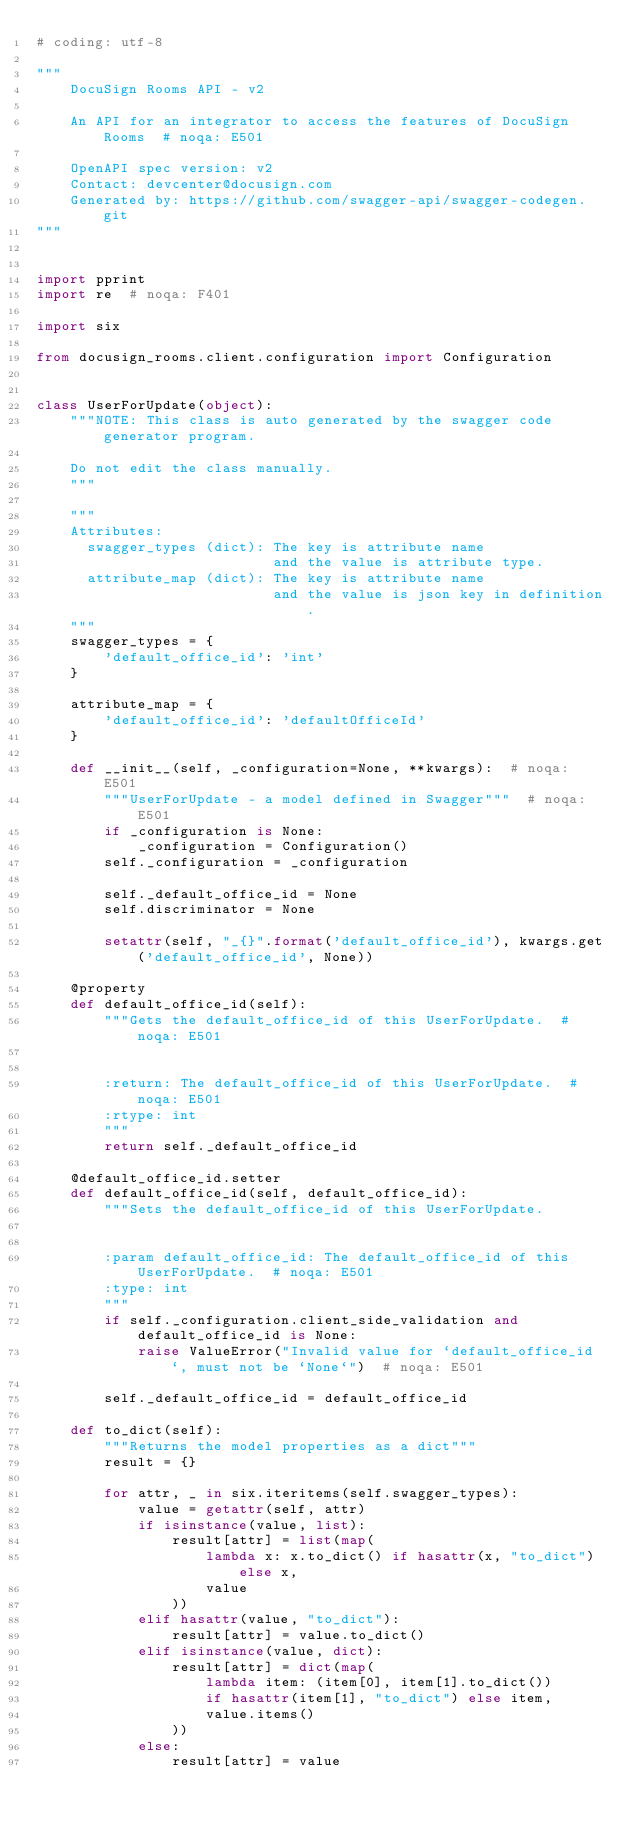Convert code to text. <code><loc_0><loc_0><loc_500><loc_500><_Python_># coding: utf-8

"""
    DocuSign Rooms API - v2

    An API for an integrator to access the features of DocuSign Rooms  # noqa: E501

    OpenAPI spec version: v2
    Contact: devcenter@docusign.com
    Generated by: https://github.com/swagger-api/swagger-codegen.git
"""


import pprint
import re  # noqa: F401

import six

from docusign_rooms.client.configuration import Configuration


class UserForUpdate(object):
    """NOTE: This class is auto generated by the swagger code generator program.

    Do not edit the class manually.
    """

    """
    Attributes:
      swagger_types (dict): The key is attribute name
                            and the value is attribute type.
      attribute_map (dict): The key is attribute name
                            and the value is json key in definition.
    """
    swagger_types = {
        'default_office_id': 'int'
    }

    attribute_map = {
        'default_office_id': 'defaultOfficeId'
    }

    def __init__(self, _configuration=None, **kwargs):  # noqa: E501
        """UserForUpdate - a model defined in Swagger"""  # noqa: E501
        if _configuration is None:
            _configuration = Configuration()
        self._configuration = _configuration

        self._default_office_id = None
        self.discriminator = None

        setattr(self, "_{}".format('default_office_id'), kwargs.get('default_office_id', None))

    @property
    def default_office_id(self):
        """Gets the default_office_id of this UserForUpdate.  # noqa: E501


        :return: The default_office_id of this UserForUpdate.  # noqa: E501
        :rtype: int
        """
        return self._default_office_id

    @default_office_id.setter
    def default_office_id(self, default_office_id):
        """Sets the default_office_id of this UserForUpdate.


        :param default_office_id: The default_office_id of this UserForUpdate.  # noqa: E501
        :type: int
        """
        if self._configuration.client_side_validation and default_office_id is None:
            raise ValueError("Invalid value for `default_office_id`, must not be `None`")  # noqa: E501

        self._default_office_id = default_office_id

    def to_dict(self):
        """Returns the model properties as a dict"""
        result = {}

        for attr, _ in six.iteritems(self.swagger_types):
            value = getattr(self, attr)
            if isinstance(value, list):
                result[attr] = list(map(
                    lambda x: x.to_dict() if hasattr(x, "to_dict") else x,
                    value
                ))
            elif hasattr(value, "to_dict"):
                result[attr] = value.to_dict()
            elif isinstance(value, dict):
                result[attr] = dict(map(
                    lambda item: (item[0], item[1].to_dict())
                    if hasattr(item[1], "to_dict") else item,
                    value.items()
                ))
            else:
                result[attr] = value</code> 